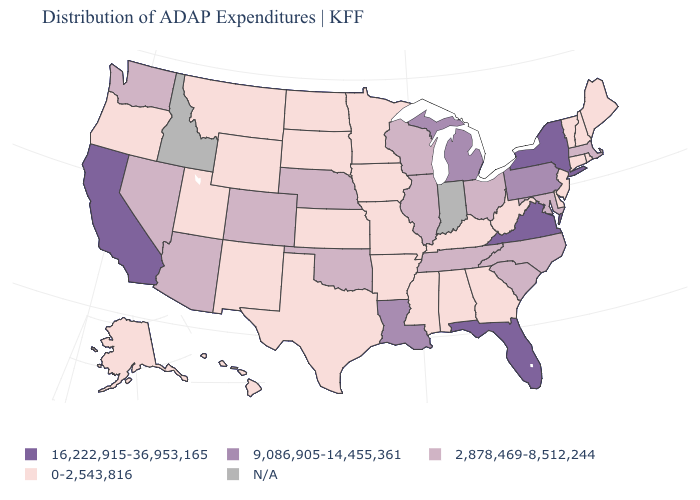Does California have the highest value in the USA?
Give a very brief answer. Yes. Does the map have missing data?
Quick response, please. Yes. Which states have the lowest value in the USA?
Be succinct. Alabama, Alaska, Arkansas, Connecticut, Delaware, Georgia, Hawaii, Iowa, Kansas, Kentucky, Maine, Minnesota, Mississippi, Missouri, Montana, New Hampshire, New Jersey, New Mexico, North Dakota, Oregon, Rhode Island, South Dakota, Texas, Utah, Vermont, West Virginia, Wyoming. What is the value of Massachusetts?
Quick response, please. 2,878,469-8,512,244. What is the value of Delaware?
Concise answer only. 0-2,543,816. Among the states that border Massachusetts , which have the highest value?
Quick response, please. New York. What is the highest value in the West ?
Concise answer only. 16,222,915-36,953,165. Name the states that have a value in the range 16,222,915-36,953,165?
Be succinct. California, Florida, New York, Virginia. Does Alabama have the highest value in the USA?
Keep it brief. No. Which states have the highest value in the USA?
Quick response, please. California, Florida, New York, Virginia. Name the states that have a value in the range 9,086,905-14,455,361?
Write a very short answer. Louisiana, Michigan, Pennsylvania. What is the value of Pennsylvania?
Concise answer only. 9,086,905-14,455,361. Name the states that have a value in the range 2,878,469-8,512,244?
Answer briefly. Arizona, Colorado, Illinois, Maryland, Massachusetts, Nebraska, Nevada, North Carolina, Ohio, Oklahoma, South Carolina, Tennessee, Washington, Wisconsin. What is the value of Hawaii?
Give a very brief answer. 0-2,543,816. What is the highest value in the Northeast ?
Quick response, please. 16,222,915-36,953,165. 